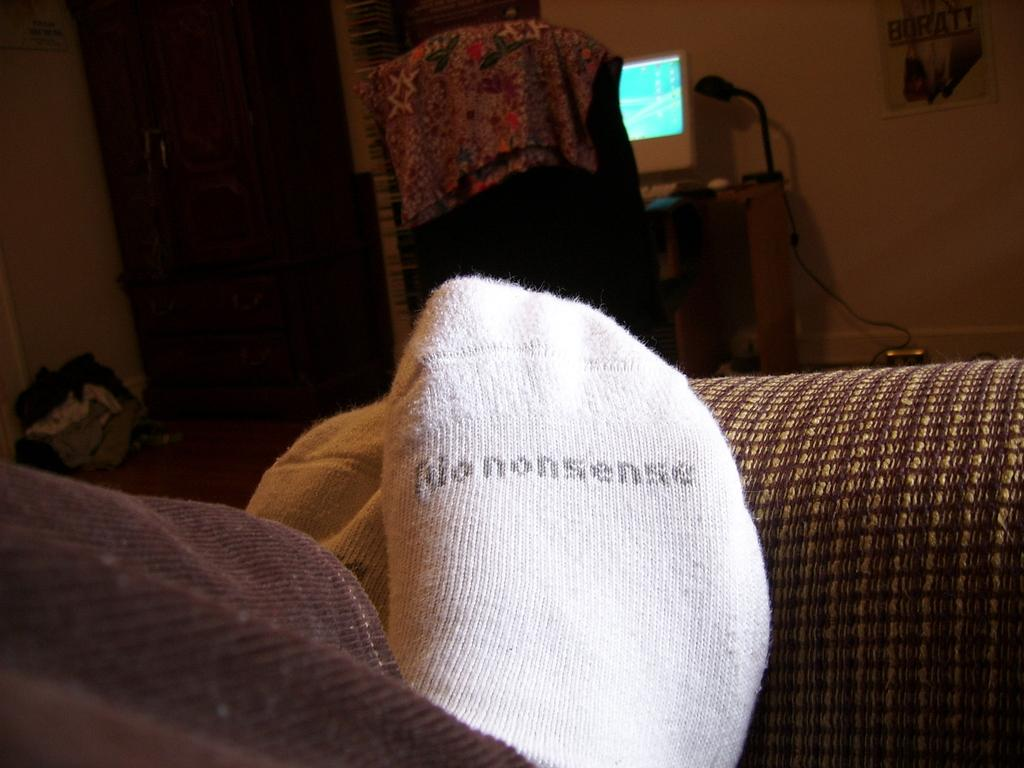What body part is visible in the image? The image shows a person's legs. What type of clothing is the person wearing on their feet? The person is wearing socks. What can be seen in the background or surrounding the person's legs? There is a screen visible in the image, and there are other unspecified objects around the person's legs. How does the person use the scarf to beam messages in the image? There is no scarf or beam of messages present in the image. 